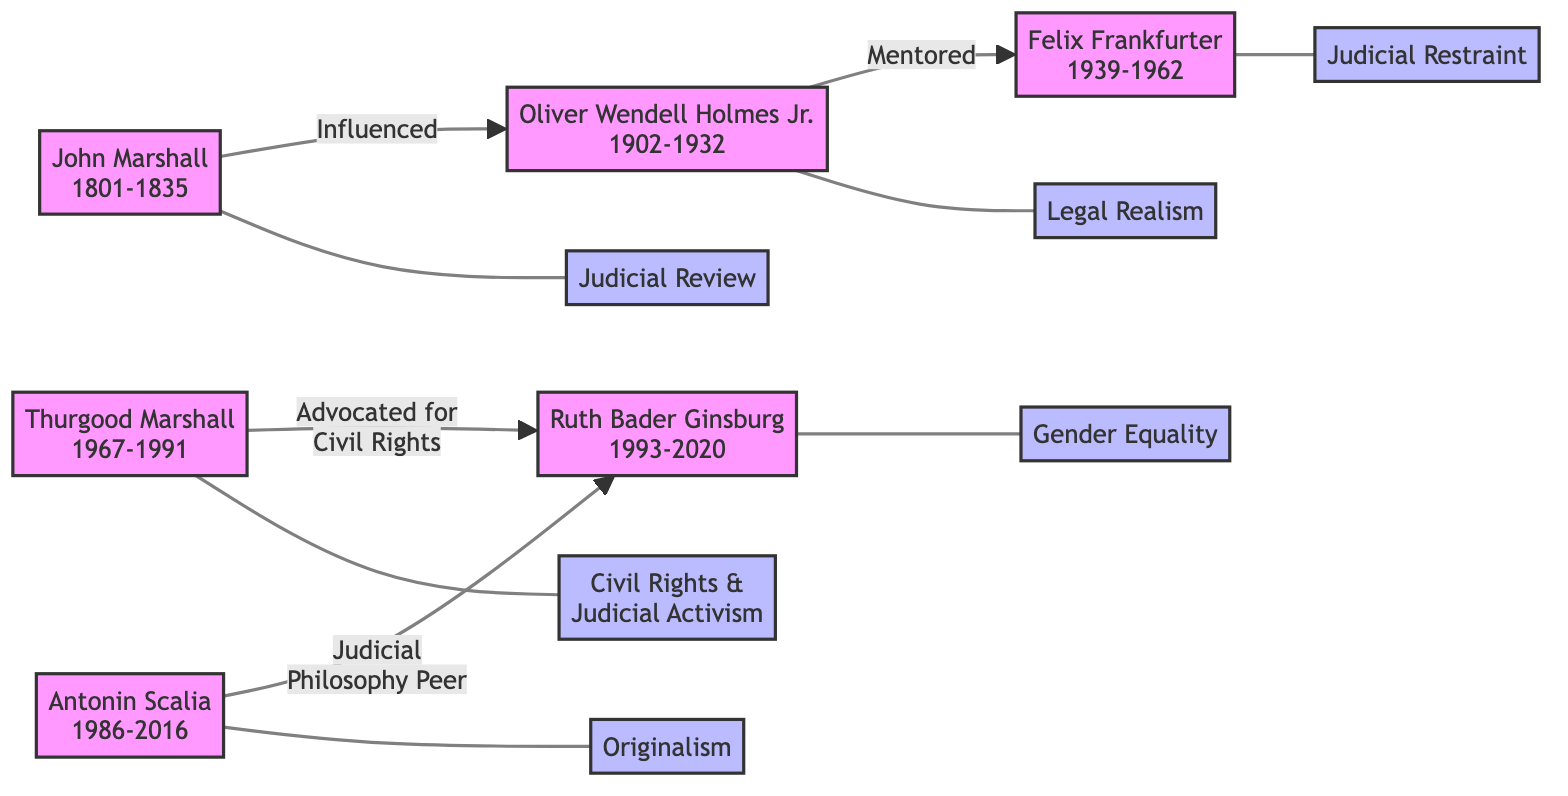What is the key theory associated with Thurgood Marshall? The diagram shows that Thurgood Marshall's key theory is "Civil Rights & Judicial Activism," as indicated by his node labeled with this theory.
Answer: Civil Rights & Judicial Activism How many Supreme Court Justices are represented in the diagram? Counting the nodes representing Supreme Court Justices, there are six named individuals: John Marshall, Oliver Wendell Holmes Jr., Felix Frankfurter, Thurgood Marshall, Antonin Scalia, and Ruth Bader Ginsburg.
Answer: 6 Who influenced Oliver Wendell Holmes Jr.? The directed edge from John Marshall to Oliver Wendell Holmes Jr. labeled "Influenced" indicates that John Marshall is the one who influenced him.
Answer: John Marshall Which justice is associated with Originalism? The node for Antonin Scalia clearly indicates that the key theory associated with him is "Originalism," shown in the diagram.
Answer: Originalism What relationship exists between Thurgood Marshall and Ruth Bader Ginsburg? The diagram shows a directed edge from Thurgood Marshall to Ruth Bader Ginsburg labeled "Advocated for Civil Rights," indicating that he actively supported her in this area.
Answer: Advocated for Civil Rights Which two justices have a relationship described as "Judicial Philosophy Peer"? The diagram has a directed edge labeled "Judicial Philosophy Peer" from Antonin Scalia to Ruth Bader Ginsburg, showing their professional relationship in terms of judicial philosophy.
Answer: Antonin Scalia and Ruth Bader Ginsburg How many types of key theories are demonstrated in the diagram? The diagram lists six key theories corresponding to each justice, namely Judicial Review, Legal Realism, Judicial Restraint, Civil Rights & Judicial Activism, Originalism, and Gender Equality, thus counting them gives the total.
Answer: 6 Who mentored Felix Frankfurter? Looking at the directed edge from Oliver Wendell Holmes Jr. to Felix Frankfurter labeled "Mentored," it is clear that Oliver Wendell Holmes Jr. mentored him.
Answer: Oliver Wendell Holmes Jr 